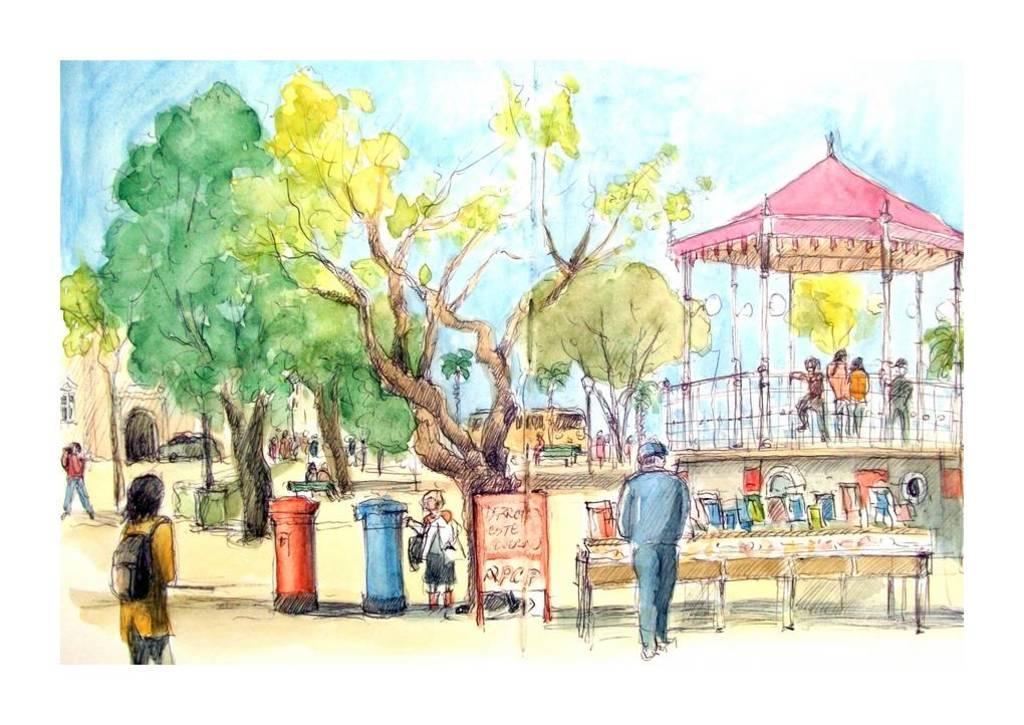Could you give a brief overview of what you see in this image? In this picture I can see the drawing. In drawing I can see trees. I can see people on the surface. I can see the vehicles. I can see the house. I can see the metal grill fence. I can see the tent. I can see post boxes. 